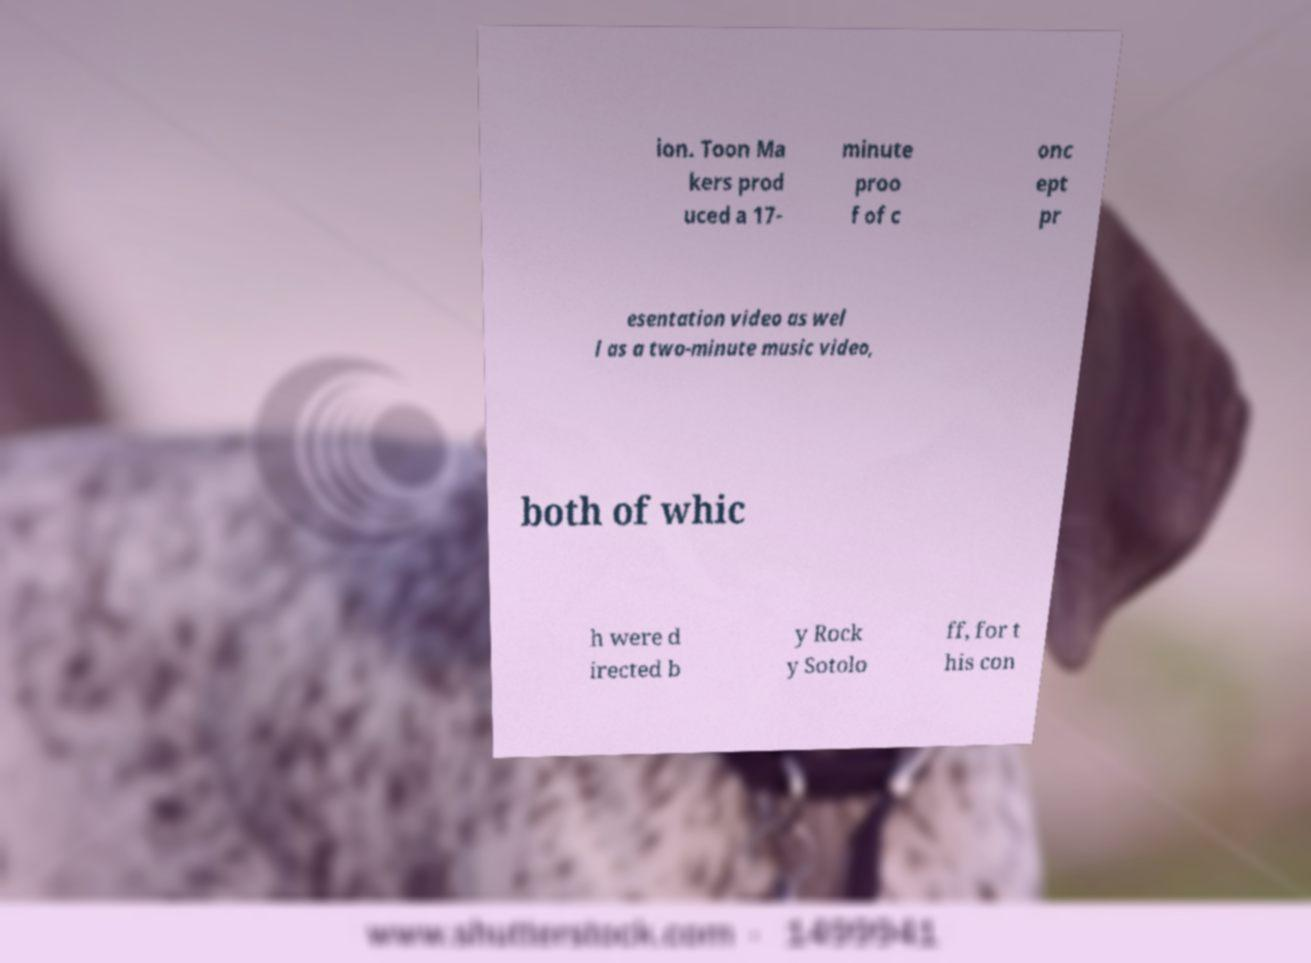For documentation purposes, I need the text within this image transcribed. Could you provide that? ion. Toon Ma kers prod uced a 17- minute proo f of c onc ept pr esentation video as wel l as a two-minute music video, both of whic h were d irected b y Rock y Sotolo ff, for t his con 